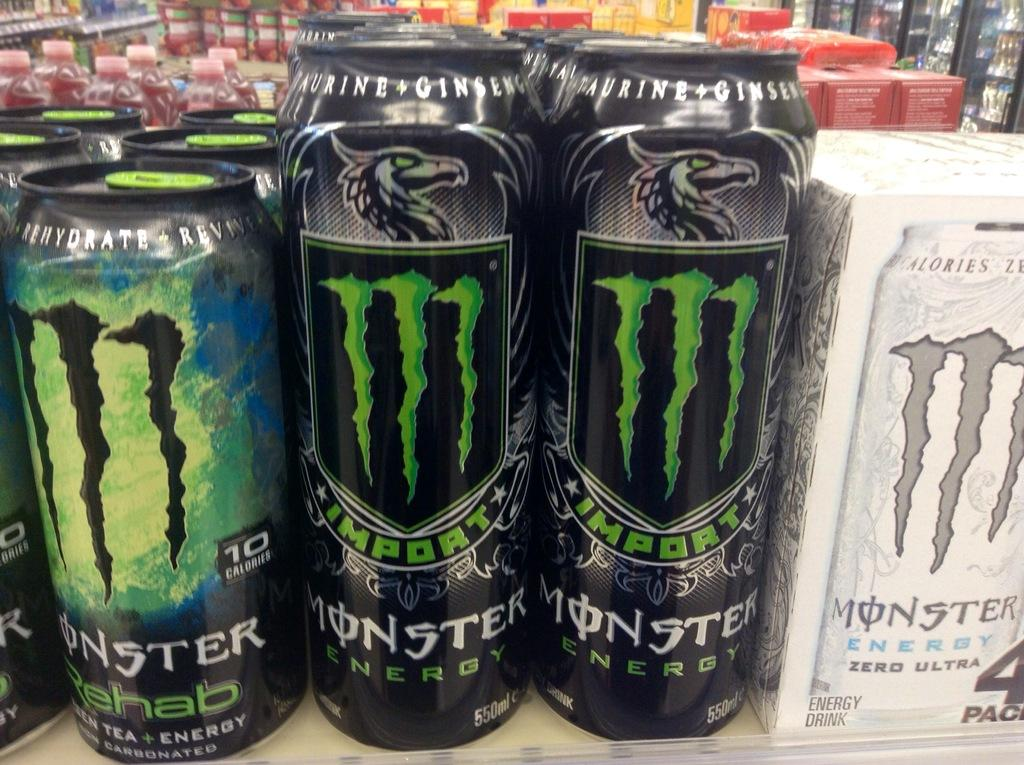<image>
Share a concise interpretation of the image provided. cans in rows of monster energy drinks next to a box of monsters 